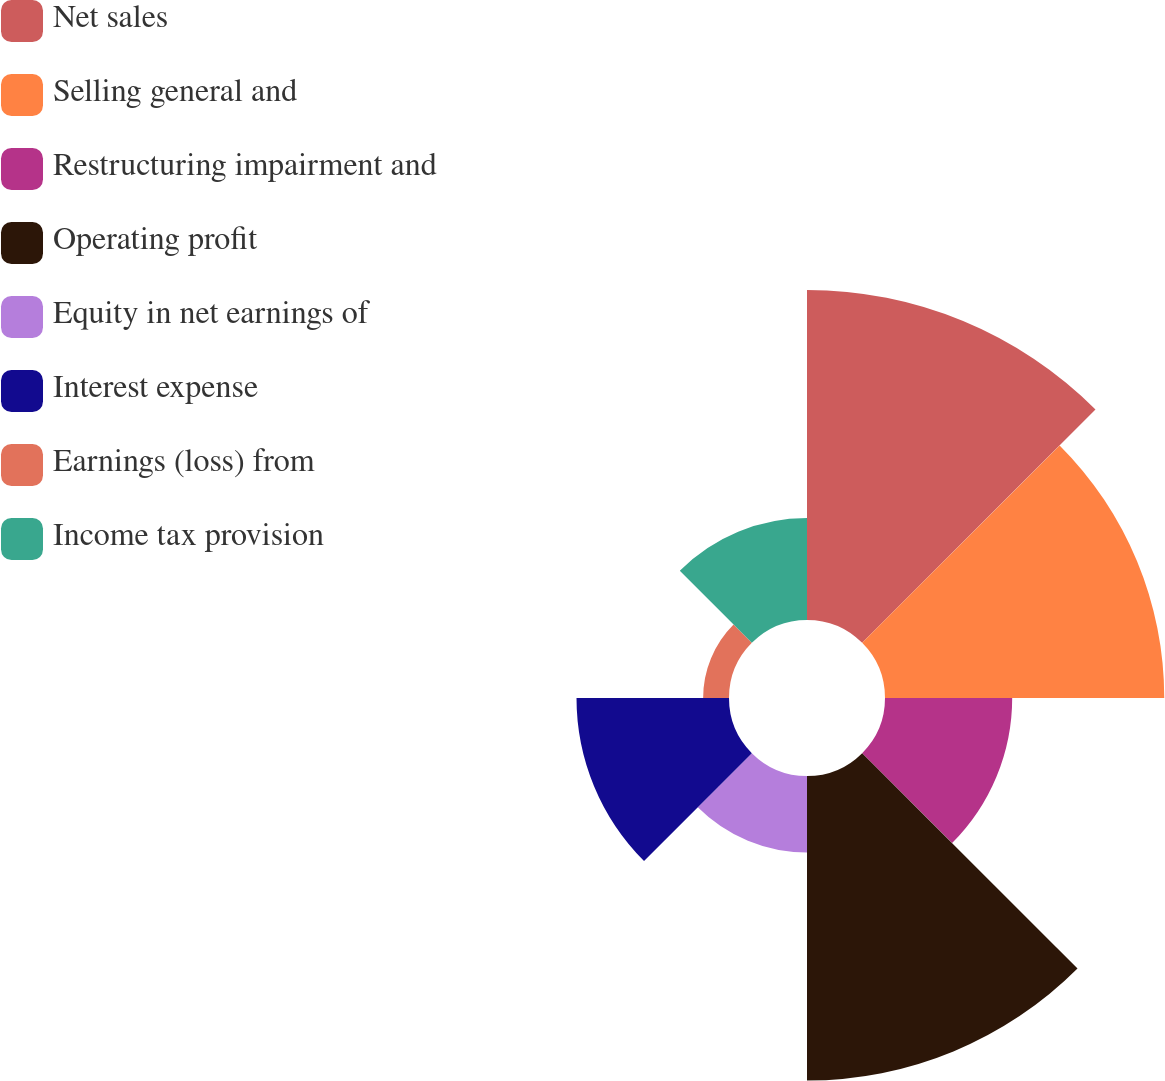<chart> <loc_0><loc_0><loc_500><loc_500><pie_chart><fcel>Net sales<fcel>Selling general and<fcel>Restructuring impairment and<fcel>Operating profit<fcel>Equity in net earnings of<fcel>Interest expense<fcel>Earnings (loss) from<fcel>Income tax provision<nl><fcel>23.61%<fcel>19.98%<fcel>9.1%<fcel>21.79%<fcel>5.47%<fcel>10.91%<fcel>1.85%<fcel>7.29%<nl></chart> 